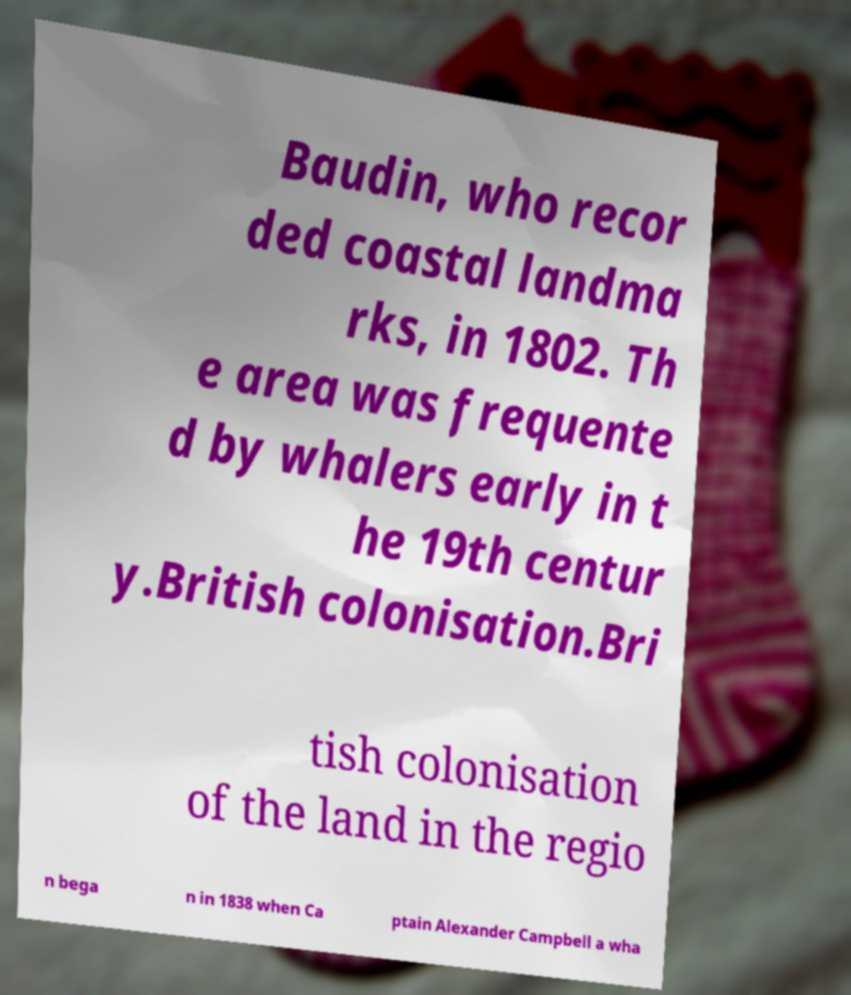What messages or text are displayed in this image? I need them in a readable, typed format. Baudin, who recor ded coastal landma rks, in 1802. Th e area was frequente d by whalers early in t he 19th centur y.British colonisation.Bri tish colonisation of the land in the regio n bega n in 1838 when Ca ptain Alexander Campbell a wha 